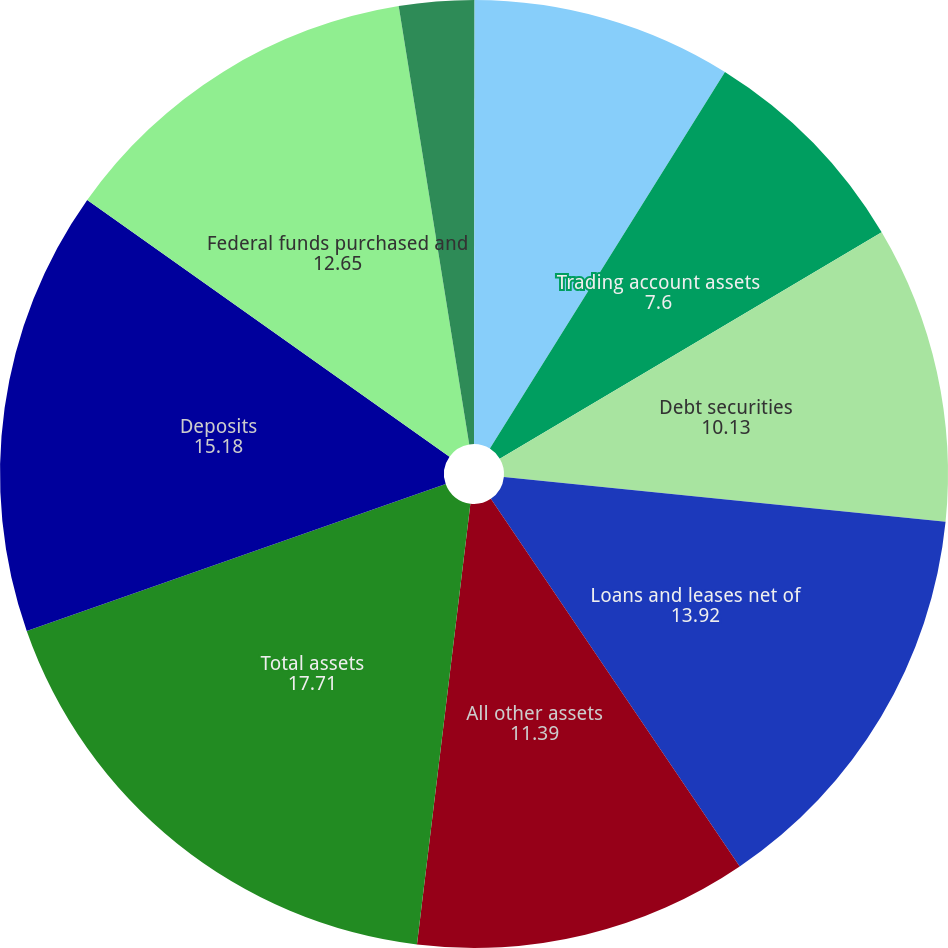Convert chart to OTSL. <chart><loc_0><loc_0><loc_500><loc_500><pie_chart><fcel>(Dollars in millions)<fcel>Federal funds sold and<fcel>Trading account assets<fcel>Debt securities<fcel>Loans and leases net of<fcel>All other assets<fcel>Total assets<fcel>Deposits<fcel>Federal funds purchased and<fcel>Trading account liabilities<nl><fcel>0.02%<fcel>8.86%<fcel>7.6%<fcel>10.13%<fcel>13.92%<fcel>11.39%<fcel>17.71%<fcel>15.18%<fcel>12.65%<fcel>2.54%<nl></chart> 